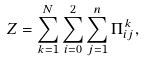Convert formula to latex. <formula><loc_0><loc_0><loc_500><loc_500>Z = \sum _ { k = 1 } ^ { N } { \sum _ { i = 0 } ^ { 2 } { \sum _ { j = 1 } ^ { n } { \Pi _ { i j } ^ { k } } } } ,</formula> 